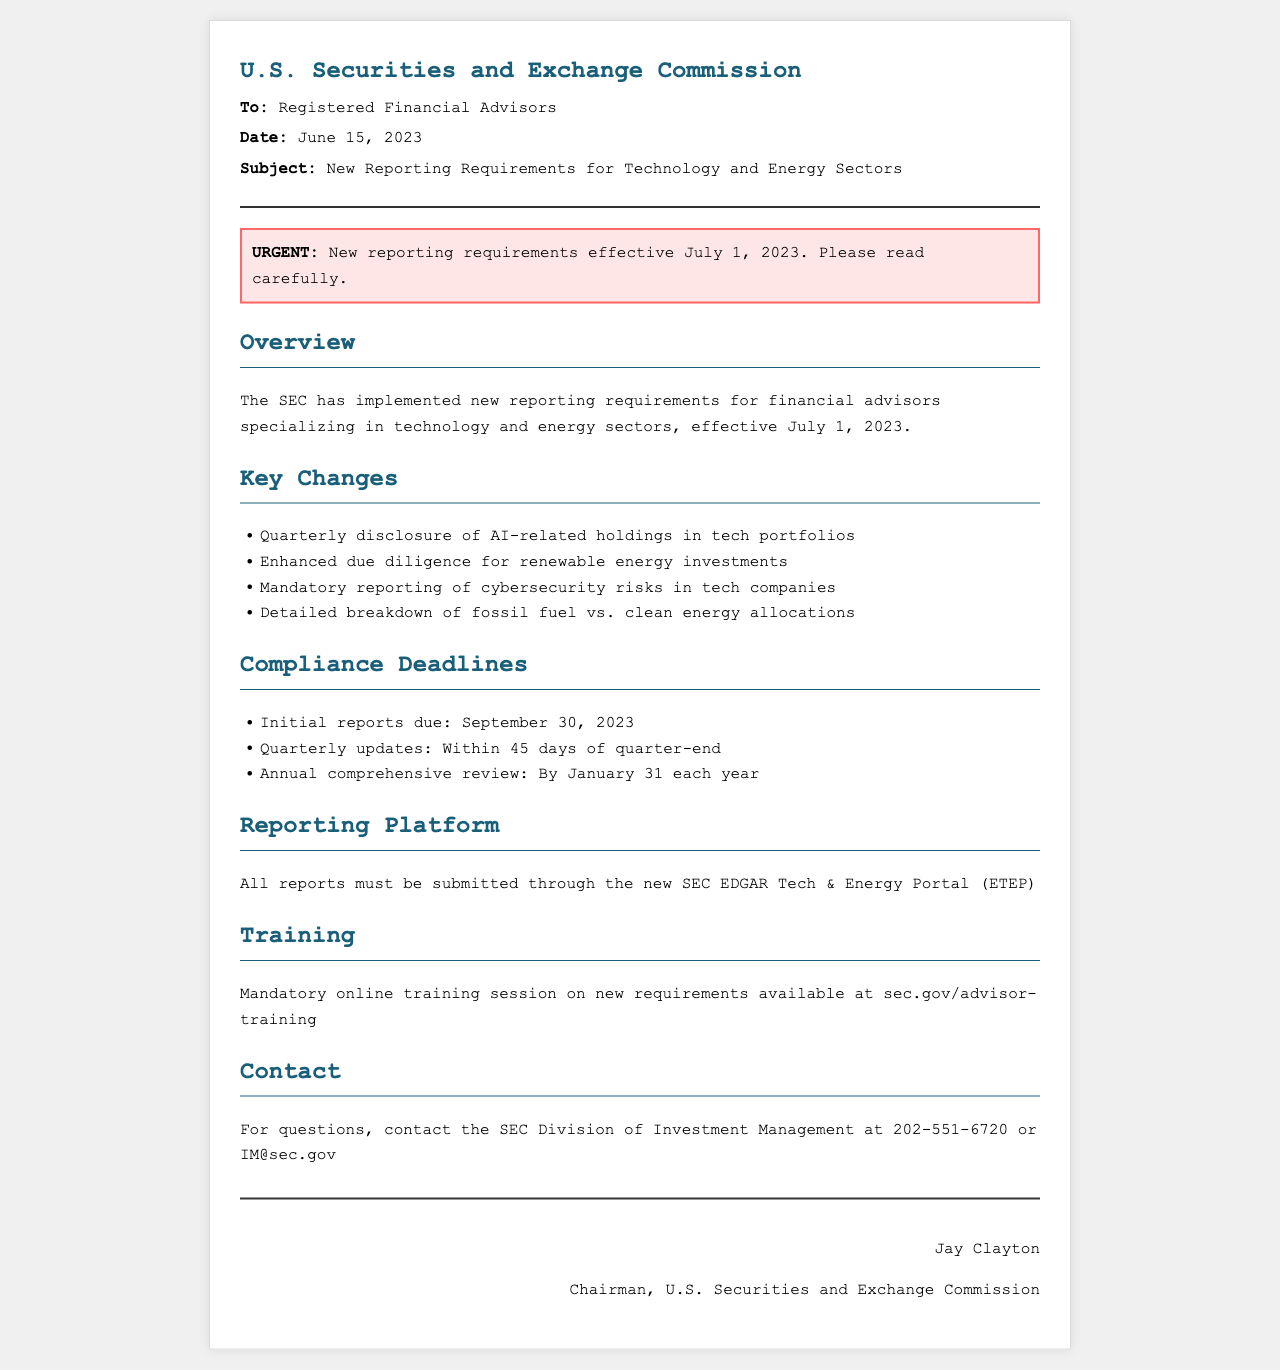what are the new reporting requirements effective date? The document states that the new reporting requirements are effective from July 1, 2023.
Answer: July 1, 2023 who should adhere to the new requirements? The document specifies that the requirements apply to registered financial advisors.
Answer: Registered financial advisors what is one of the key changes regarding tech portfolios? The document mentions that there is a requirement for quarterly disclosure of AI-related holdings in tech portfolios.
Answer: Quarterly disclosure of AI-related holdings when are initial reports due? According to the document, the initial reports are due by September 30, 2023.
Answer: September 30, 2023 what is the name of the reporting platform? The document mentions that reports must be submitted through the SEC EDGAR Tech & Energy Portal (ETEP).
Answer: ETEP what is required for renewable energy investments? The document indicates that enhanced due diligence is now required for renewable energy investments.
Answer: Enhanced due diligence what should financial advisors do for training on the new requirements? The document states that mandatory online training sessions are available at sec.gov/advisor-training.
Answer: Mandatory online training session who can be contacted for questions regarding the update? The document provides a contact number for the SEC Division of Investment Management for inquiries.
Answer: SEC Division of Investment Management what is the annual comprehensive review deadline? The document states that the annual comprehensive review is due by January 31 each year.
Answer: January 31 each year 